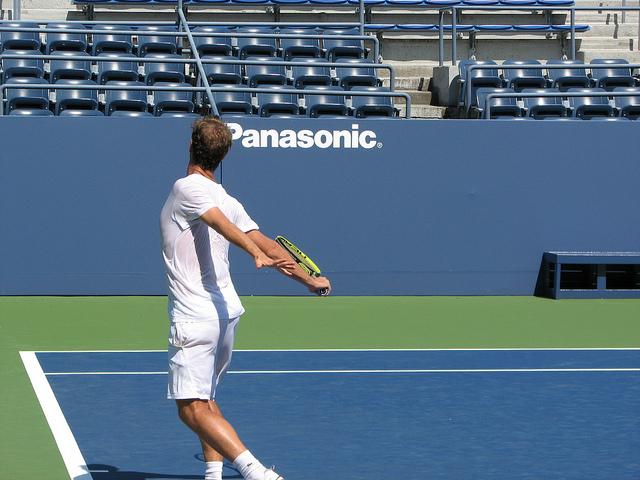What color are the seats?
Concise answer only. Blue. Is there a crowd of people?
Keep it brief. No. What word is here?
Give a very brief answer. Panasonic. What game is being played?
Quick response, please. Tennis. 